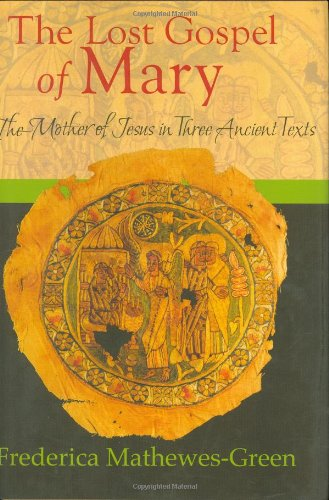Could you explain the historical significance of the texts mentioned in the title? The texts referred to in the title encompass ancient writings that offer insights into the life and perceptions of Mary, the mother of Jesus, in early Christianity. These documents are crucial for understanding the veneration of Mary in various early Christian communities and their theological implications. 